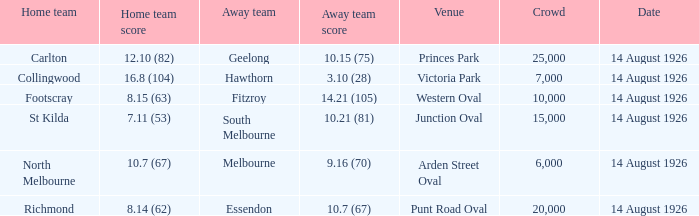How many people, in total, have watched north melbourne play at home? 6000.0. 